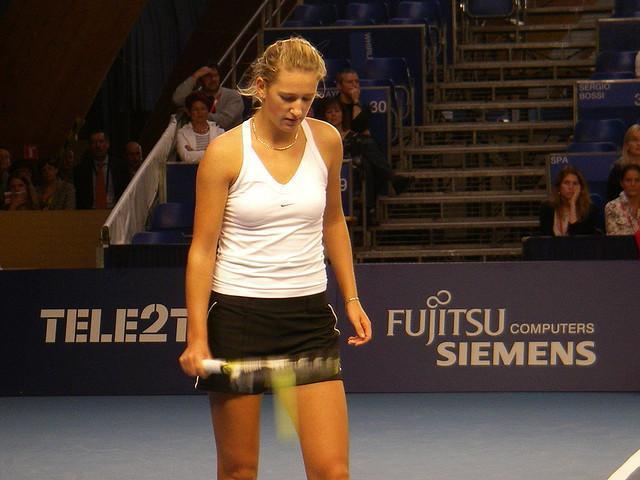How many people are there?
Give a very brief answer. 6. How many hot dogs are there in the picture?
Give a very brief answer. 0. 